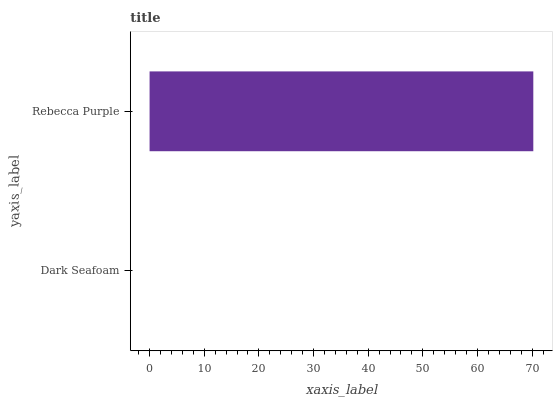Is Dark Seafoam the minimum?
Answer yes or no. Yes. Is Rebecca Purple the maximum?
Answer yes or no. Yes. Is Rebecca Purple the minimum?
Answer yes or no. No. Is Rebecca Purple greater than Dark Seafoam?
Answer yes or no. Yes. Is Dark Seafoam less than Rebecca Purple?
Answer yes or no. Yes. Is Dark Seafoam greater than Rebecca Purple?
Answer yes or no. No. Is Rebecca Purple less than Dark Seafoam?
Answer yes or no. No. Is Rebecca Purple the high median?
Answer yes or no. Yes. Is Dark Seafoam the low median?
Answer yes or no. Yes. Is Dark Seafoam the high median?
Answer yes or no. No. Is Rebecca Purple the low median?
Answer yes or no. No. 